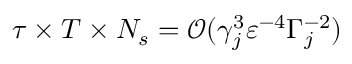Convert formula to latex. <formula><loc_0><loc_0><loc_500><loc_500>\tau \times T \times N _ { s } = \mathcal { O } ( \gamma _ { j } ^ { 3 } \varepsilon ^ { - 4 } \Gamma _ { j } ^ { - 2 } )</formula> 